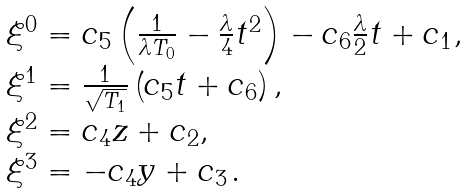<formula> <loc_0><loc_0><loc_500><loc_500>\begin{array} { l } \xi ^ { 0 } = c _ { 5 } \left ( \frac { 1 } { \lambda T _ { 0 } } - \frac { \lambda } { 4 } t ^ { 2 } \right ) - c _ { 6 } \frac { \lambda } { 2 } t + c _ { 1 } , \\ \xi ^ { 1 } = \frac { 1 } { \sqrt { T _ { 1 } } } \left ( c _ { 5 } t + c _ { 6 } \right ) , \\ \xi ^ { 2 } = c _ { 4 } z + c _ { 2 } , \\ \xi ^ { 3 } = - c _ { 4 } y + c _ { 3 \, } . \end{array}</formula> 